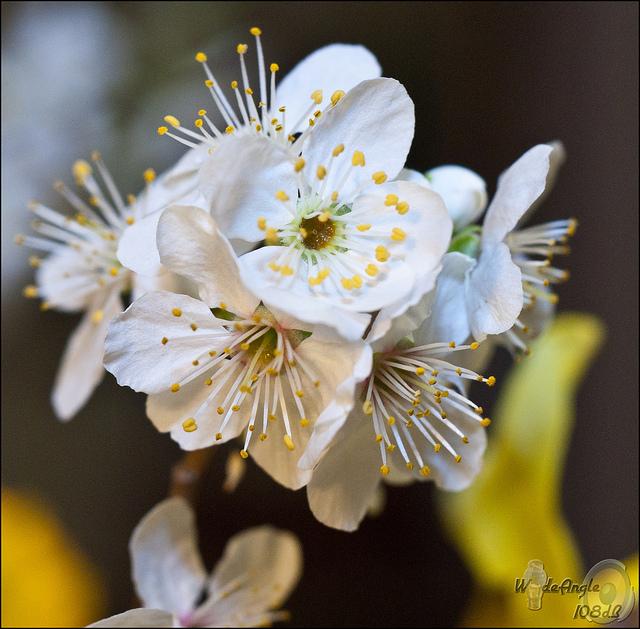What type of flower is pictured?
Be succinct. Lily. Is there only one flower?
Write a very short answer. No. How many yellow dots are on the flower?
Short answer required. 0. 